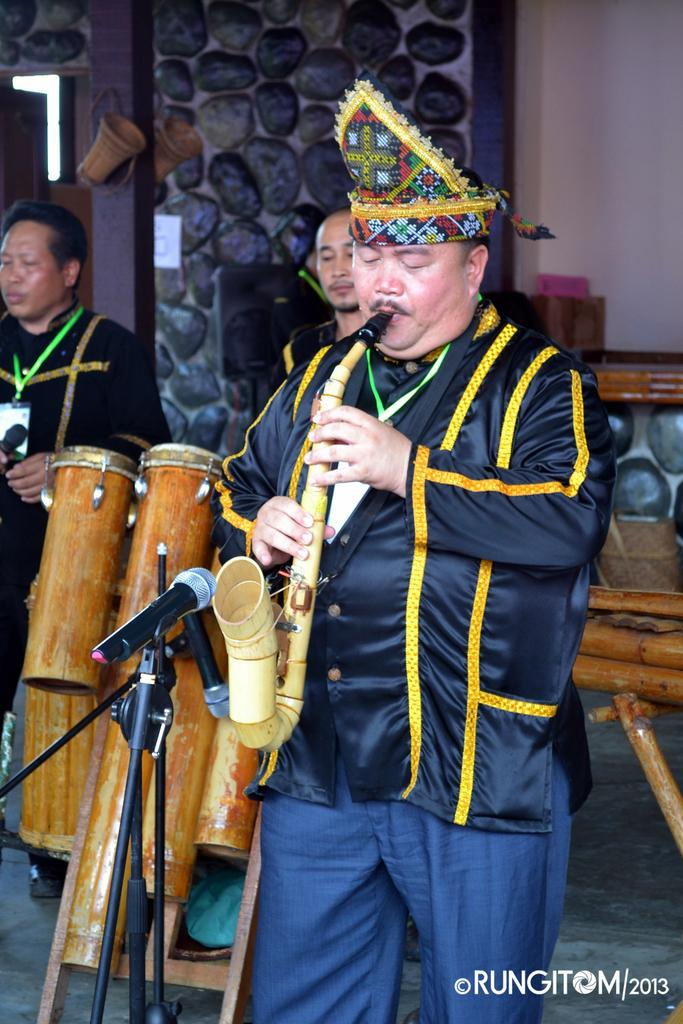What is the person in the image doing? The person is playing a musical instrument in the image. What material is the musical instrument made of? The musical instrument is made of wood. What can be seen in the background of the image? There is a wall visible in the image. How many passengers are visible in the image? There are no passengers present in the image; it features a person playing a musical instrument. What type of grip does the musical instrument have on the wall? The musical instrument is not attached to the wall, and therefore it does not have a grip on the wall. 